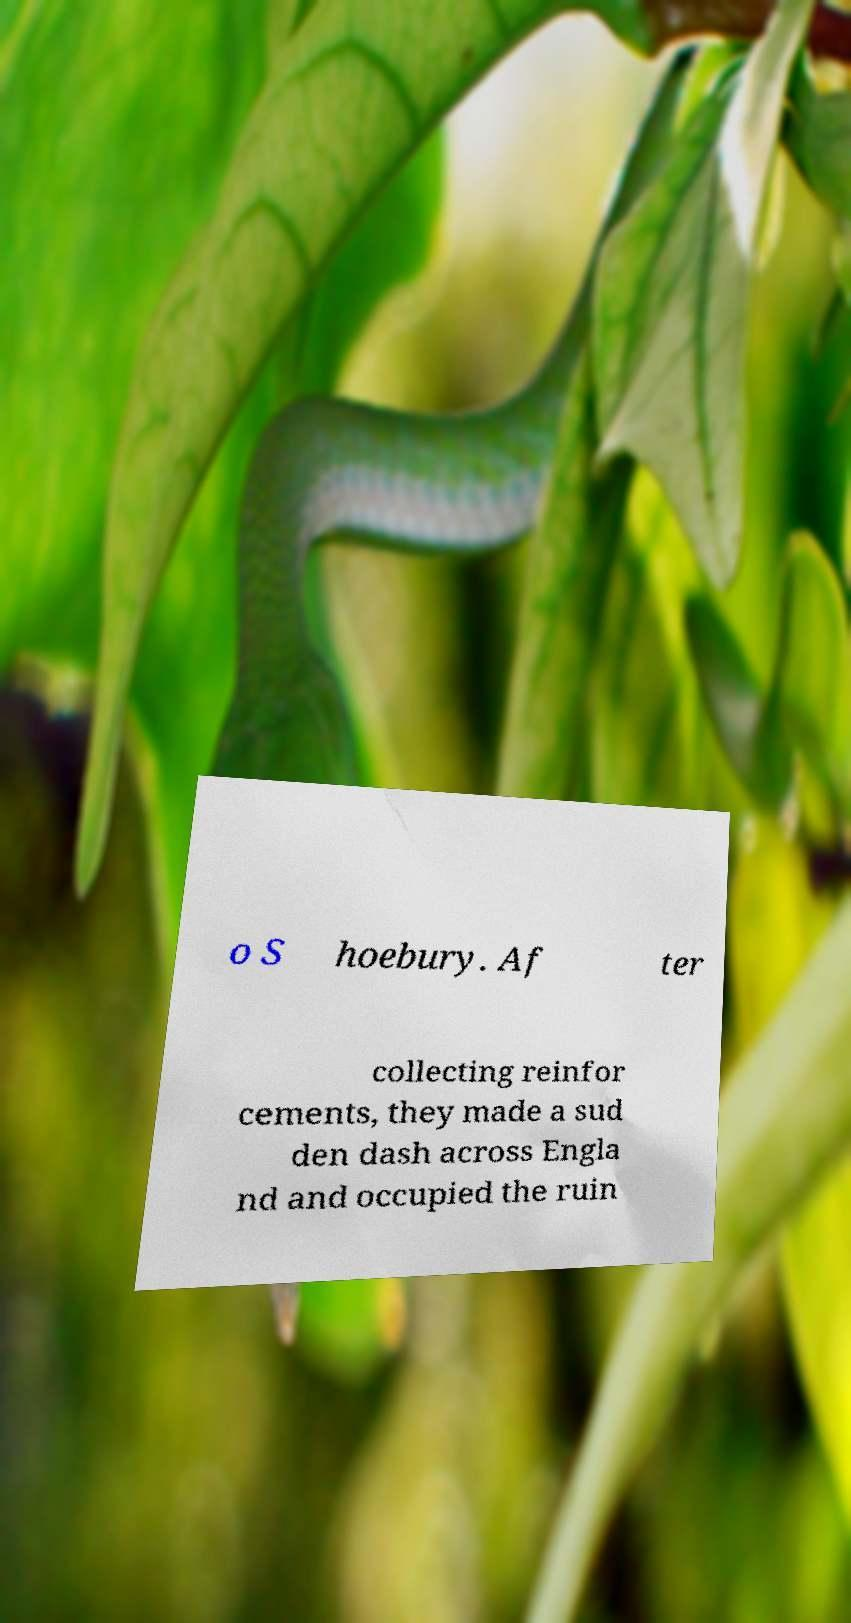Could you assist in decoding the text presented in this image and type it out clearly? o S hoebury. Af ter collecting reinfor cements, they made a sud den dash across Engla nd and occupied the ruin 